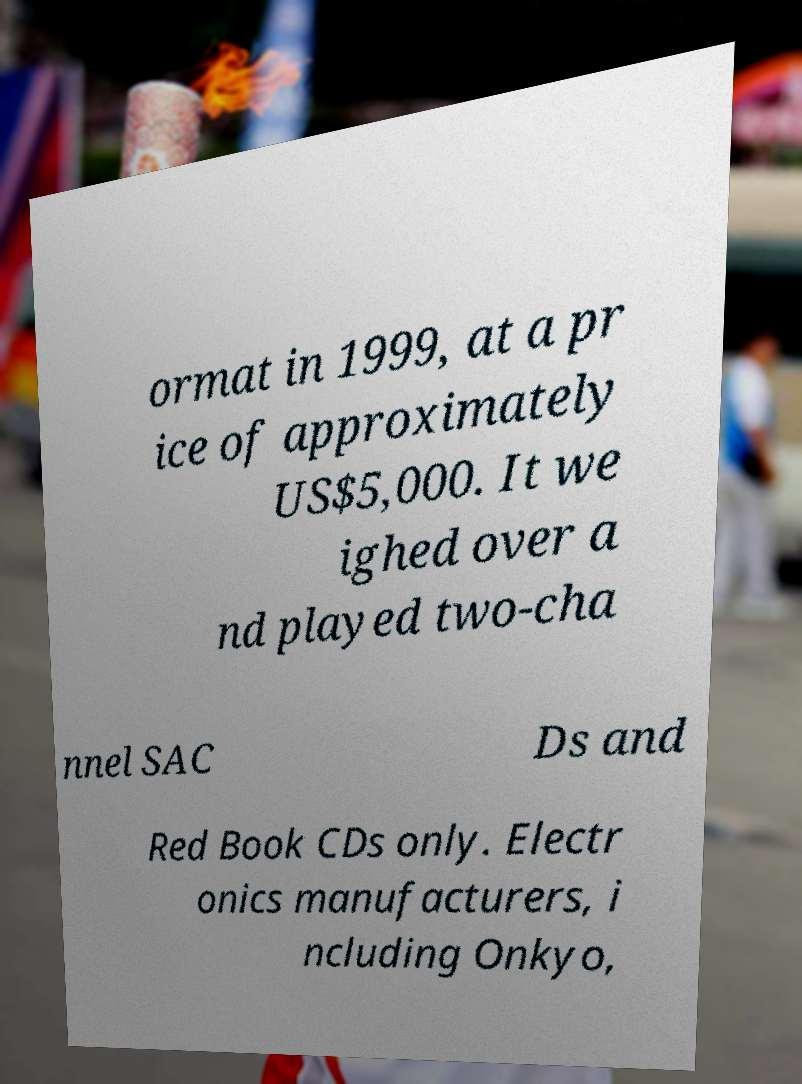Can you accurately transcribe the text from the provided image for me? ormat in 1999, at a pr ice of approximately US$5,000. It we ighed over a nd played two-cha nnel SAC Ds and Red Book CDs only. Electr onics manufacturers, i ncluding Onkyo, 